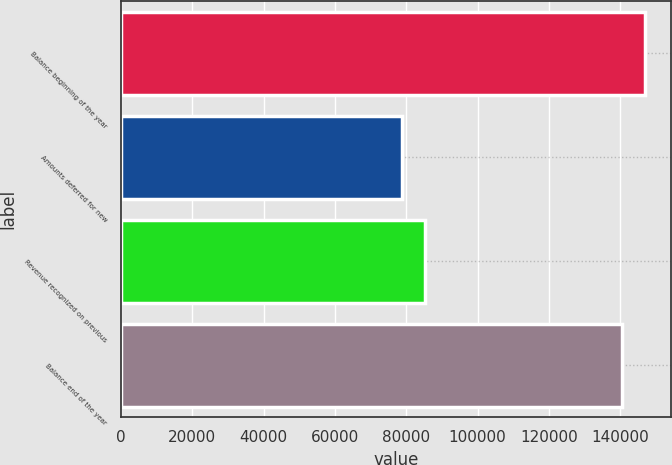Convert chart to OTSL. <chart><loc_0><loc_0><loc_500><loc_500><bar_chart><fcel>Balance beginning of the year<fcel>Amounts deferred for new<fcel>Revenue recognized on previous<fcel>Balance end of the year<nl><fcel>146909<fcel>78913<fcel>85239<fcel>140583<nl></chart> 